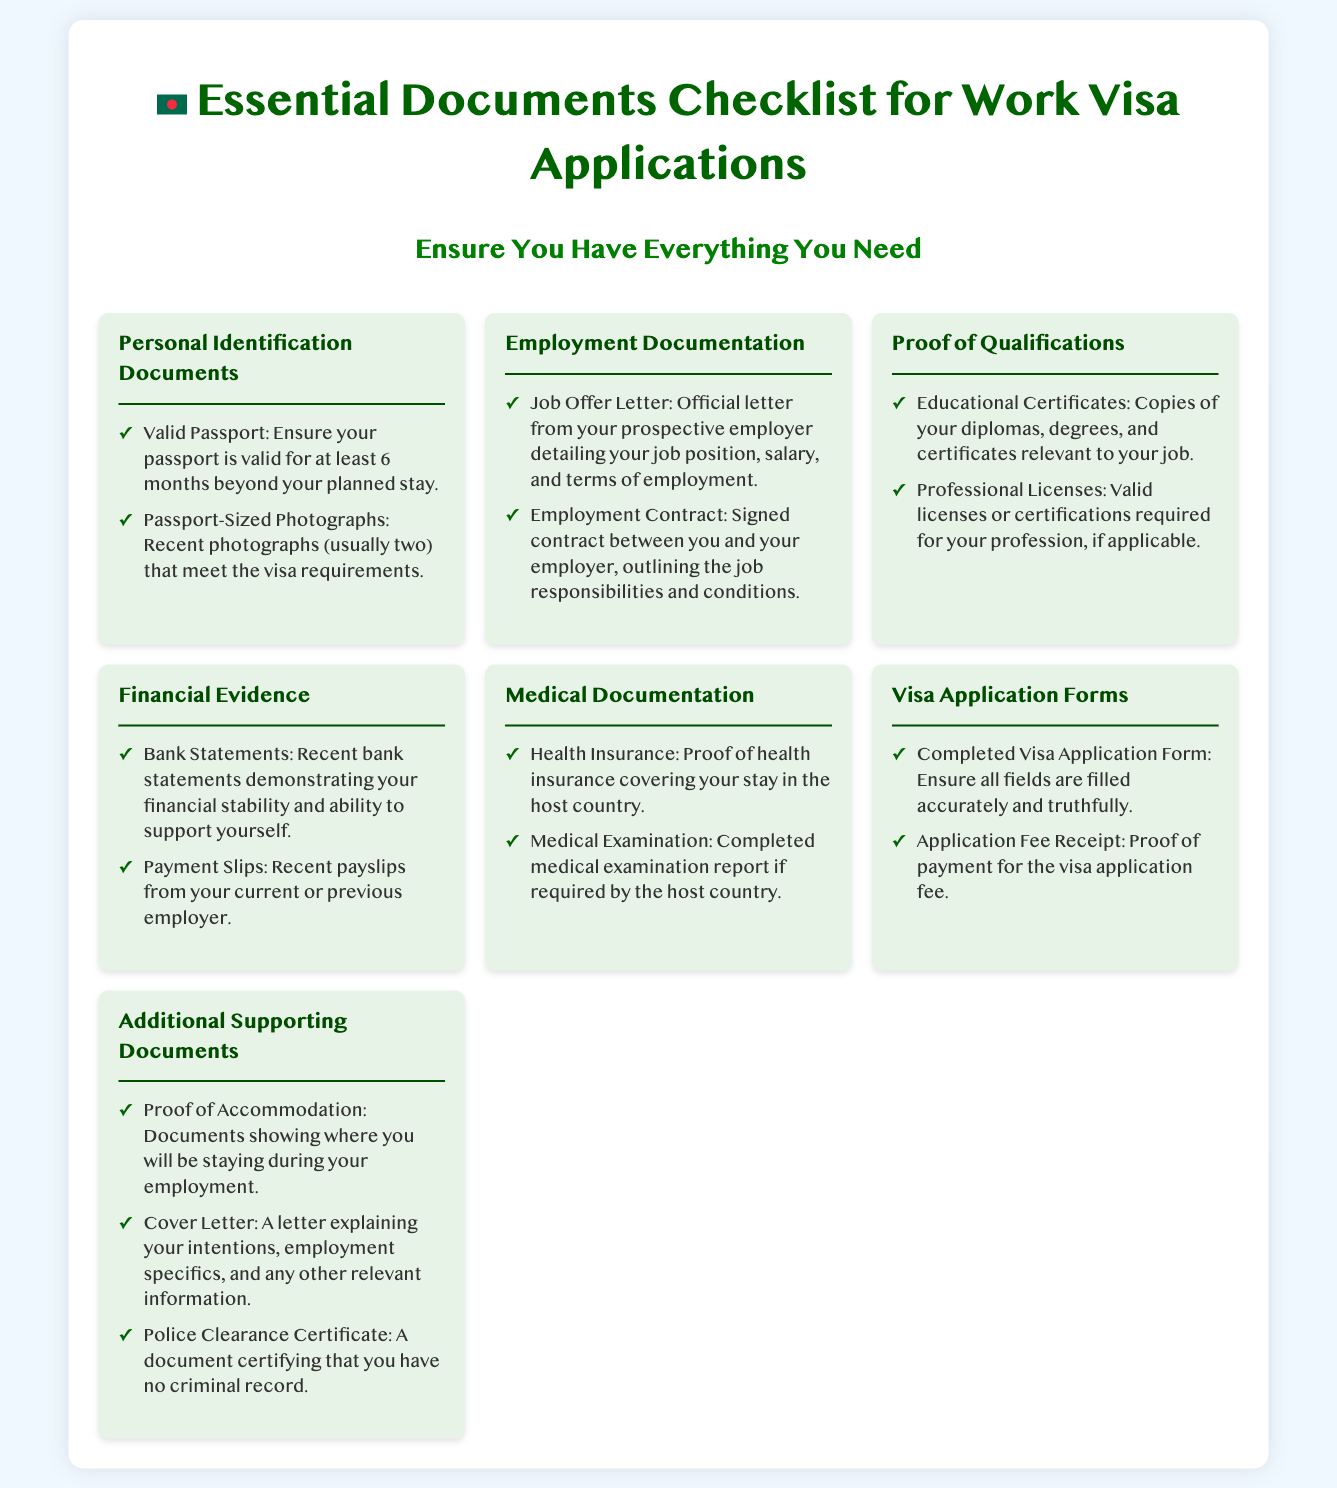what is the minimum passport validity required? The document states that your passport must be valid for at least 6 months beyond your planned stay.
Answer: 6 months how many passport-sized photographs are needed? The checklist mentions that you typically need two recent photographs that meet the visa requirements.
Answer: Two what document certifies your employment? The essential employment document needed is the Job Offer Letter.
Answer: Job Offer Letter what type of financial evidence is required? The checklist specifies that recent bank statements are necessary to demonstrate financial stability.
Answer: Bank Statements what proof is required for health coverage? The document requires proof of health insurance covering your stay in the host country.
Answer: Health Insurance how many types of proof of qualification are listed? The section on proof of qualifications mentions two types of documents: educational certificates and professional licenses.
Answer: Two is a police clearance certificate required? The document includes the police clearance certificate in the additional supporting documents section.
Answer: Yes what must be completed along with the visa application? The checklist requires that you complete the Visa Application Form accurately and truthfully.
Answer: Visa Application Form what document confirms your accommodation? Proof of Accommodation is mentioned as a necessary document showing where you will be staying during employment.
Answer: Proof of Accommodation 